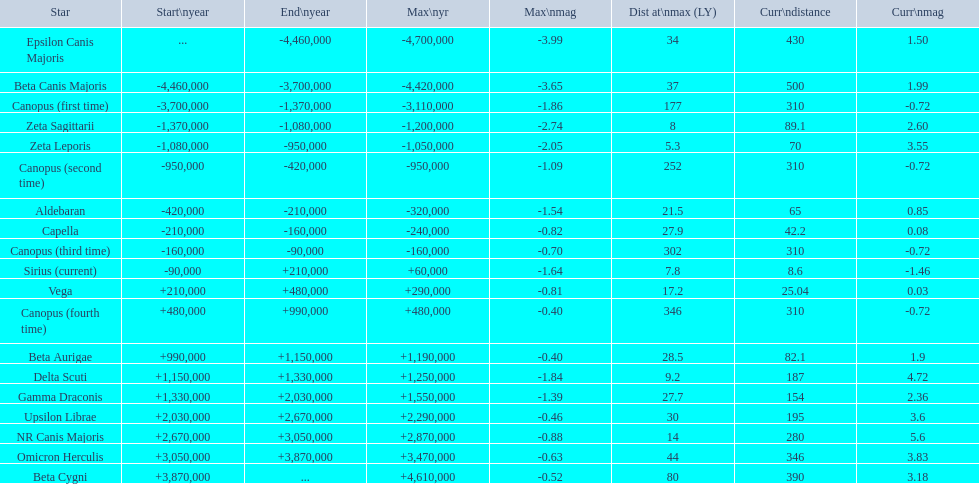In what way do the nearest and farthest current distances differ from each other? 491.4. Parse the full table. {'header': ['Star', 'Start\\nyear', 'End\\nyear', 'Max\\nyr', 'Max\\nmag', 'Dist at\\nmax (LY)', 'Curr\\ndistance', 'Curr\\nmag'], 'rows': [['Epsilon Canis Majoris', '...', '-4,460,000', '-4,700,000', '-3.99', '34', '430', '1.50'], ['Beta Canis Majoris', '-4,460,000', '-3,700,000', '-4,420,000', '-3.65', '37', '500', '1.99'], ['Canopus (first time)', '-3,700,000', '-1,370,000', '-3,110,000', '-1.86', '177', '310', '-0.72'], ['Zeta Sagittarii', '-1,370,000', '-1,080,000', '-1,200,000', '-2.74', '8', '89.1', '2.60'], ['Zeta Leporis', '-1,080,000', '-950,000', '-1,050,000', '-2.05', '5.3', '70', '3.55'], ['Canopus (second time)', '-950,000', '-420,000', '-950,000', '-1.09', '252', '310', '-0.72'], ['Aldebaran', '-420,000', '-210,000', '-320,000', '-1.54', '21.5', '65', '0.85'], ['Capella', '-210,000', '-160,000', '-240,000', '-0.82', '27.9', '42.2', '0.08'], ['Canopus (third time)', '-160,000', '-90,000', '-160,000', '-0.70', '302', '310', '-0.72'], ['Sirius (current)', '-90,000', '+210,000', '+60,000', '-1.64', '7.8', '8.6', '-1.46'], ['Vega', '+210,000', '+480,000', '+290,000', '-0.81', '17.2', '25.04', '0.03'], ['Canopus (fourth time)', '+480,000', '+990,000', '+480,000', '-0.40', '346', '310', '-0.72'], ['Beta Aurigae', '+990,000', '+1,150,000', '+1,190,000', '-0.40', '28.5', '82.1', '1.9'], ['Delta Scuti', '+1,150,000', '+1,330,000', '+1,250,000', '-1.84', '9.2', '187', '4.72'], ['Gamma Draconis', '+1,330,000', '+2,030,000', '+1,550,000', '-1.39', '27.7', '154', '2.36'], ['Upsilon Librae', '+2,030,000', '+2,670,000', '+2,290,000', '-0.46', '30', '195', '3.6'], ['NR Canis Majoris', '+2,670,000', '+3,050,000', '+2,870,000', '-0.88', '14', '280', '5.6'], ['Omicron Herculis', '+3,050,000', '+3,870,000', '+3,470,000', '-0.63', '44', '346', '3.83'], ['Beta Cygni', '+3,870,000', '...', '+4,610,000', '-0.52', '80', '390', '3.18']]} 